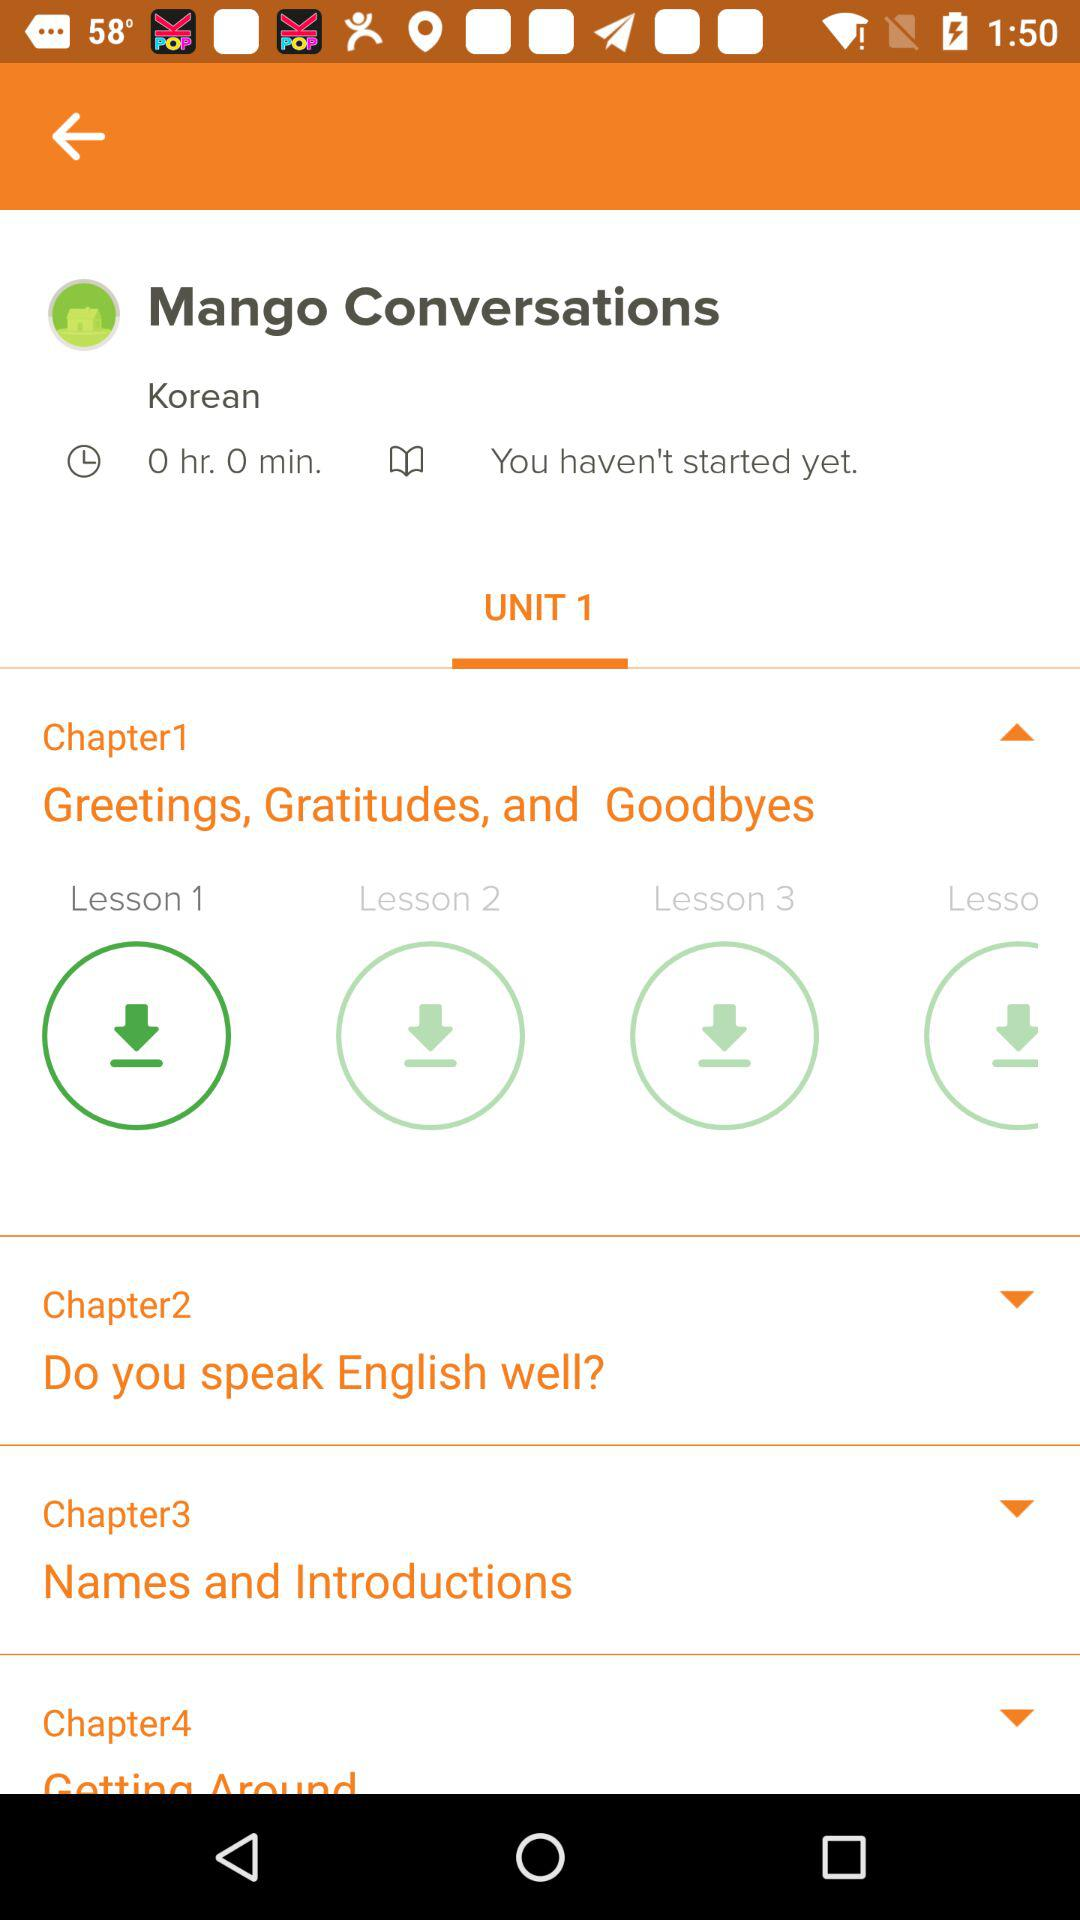What is the name of Chapter 2? The name of Chapter 2 is "Do you speak English well?". 